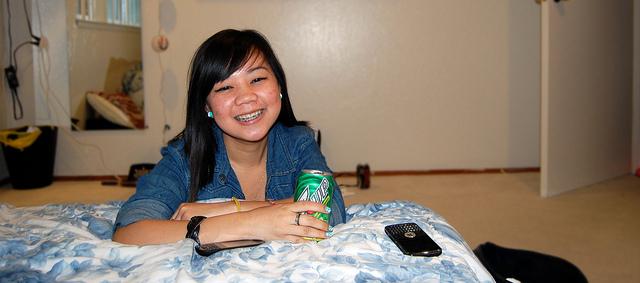Are the girl's ear's pierced?
Be succinct. Yes. What's in the girls mouth?
Give a very brief answer. Braces. What is the woman holding?
Quick response, please. Can. 